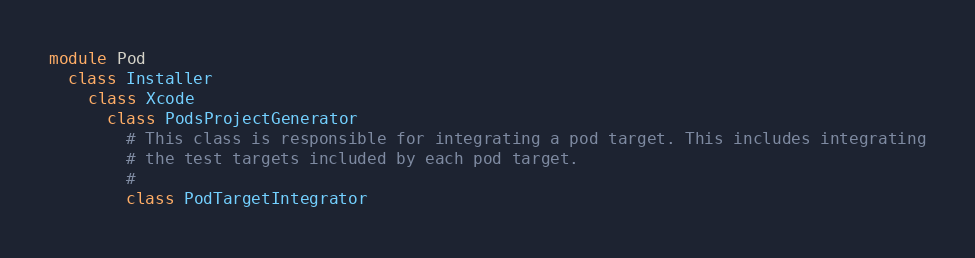<code> <loc_0><loc_0><loc_500><loc_500><_Ruby_>module Pod
  class Installer
    class Xcode
      class PodsProjectGenerator
        # This class is responsible for integrating a pod target. This includes integrating
        # the test targets included by each pod target.
        #
        class PodTargetIntegrator</code> 